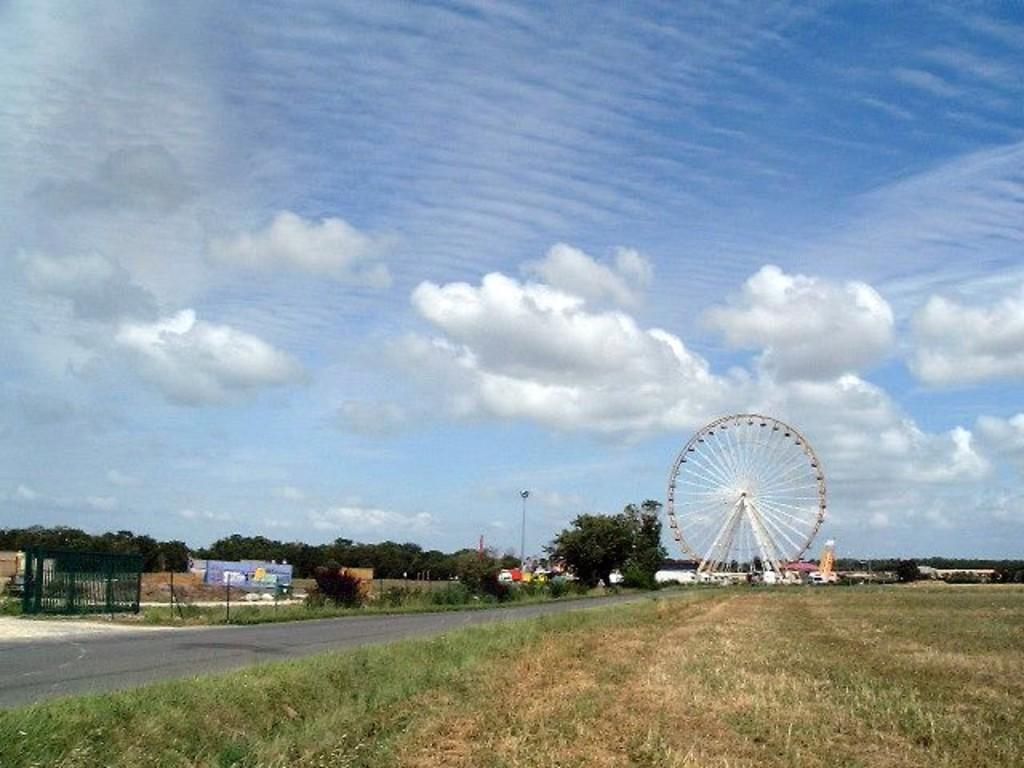What type of surface can be seen in the image? There is a road in the image. What type of vegetation is present in the image? There is grass in the image. What type of barrier can be seen in the image? There is a fence in the image. What type of vehicle is present in the image? There are vehicles in the image. What type of structure can be seen in the image? There is a joint wheel in the image. What type of objects are present in the image? There are some objects in the image. What type of natural feature can be seen in the image? There are trees in the image. What can be seen in the background of the image? The sky is visible in the background of the image, and there are clouds in the sky. Can you tell me how many goats are grazing in the grass in the image? There are no goats present in the image; it features a road, grass, a fence, vehicles, a joint wheel, objects, trees, and a sky with clouds. What type of cracker is being used to prop up the fence in the image? There is no cracker present in the image, nor is there any indication that the fence is being propped up. What type of haircut is the tree on the right side of the image getting? There is no tree on the right side of the image, and trees do not get haircuts. 